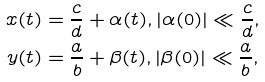<formula> <loc_0><loc_0><loc_500><loc_500>x ( t ) & = \frac { c } { d } + \alpha ( t ) , | \alpha ( 0 ) | \ll \frac { c } { d } , \\ y ( t ) & = \frac { a } { b } + \beta ( t ) , | \beta ( 0 ) | \ll \frac { a } { b } ,</formula> 